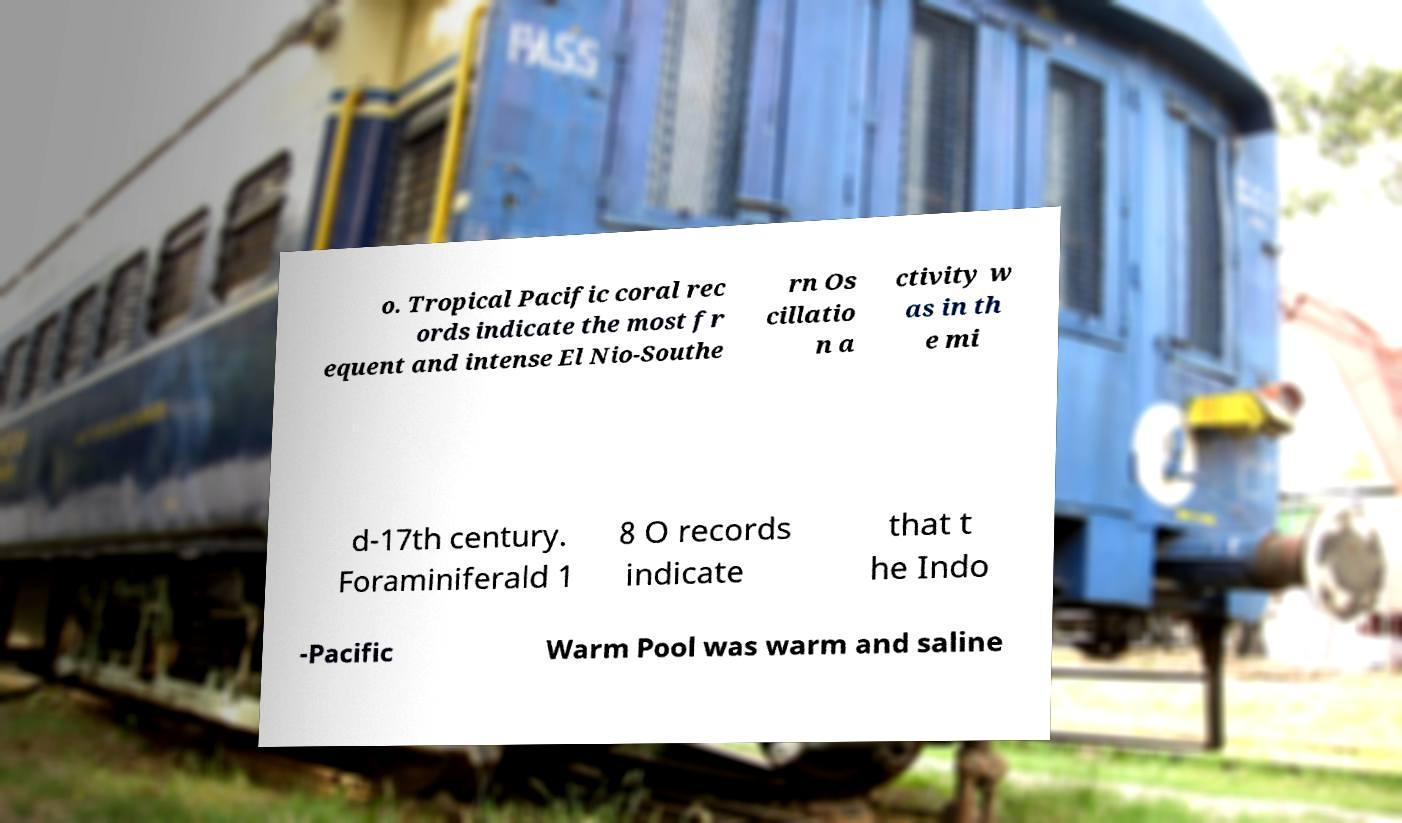Could you assist in decoding the text presented in this image and type it out clearly? o. Tropical Pacific coral rec ords indicate the most fr equent and intense El Nio-Southe rn Os cillatio n a ctivity w as in th e mi d-17th century. Foraminiferald 1 8 O records indicate that t he Indo -Pacific Warm Pool was warm and saline 